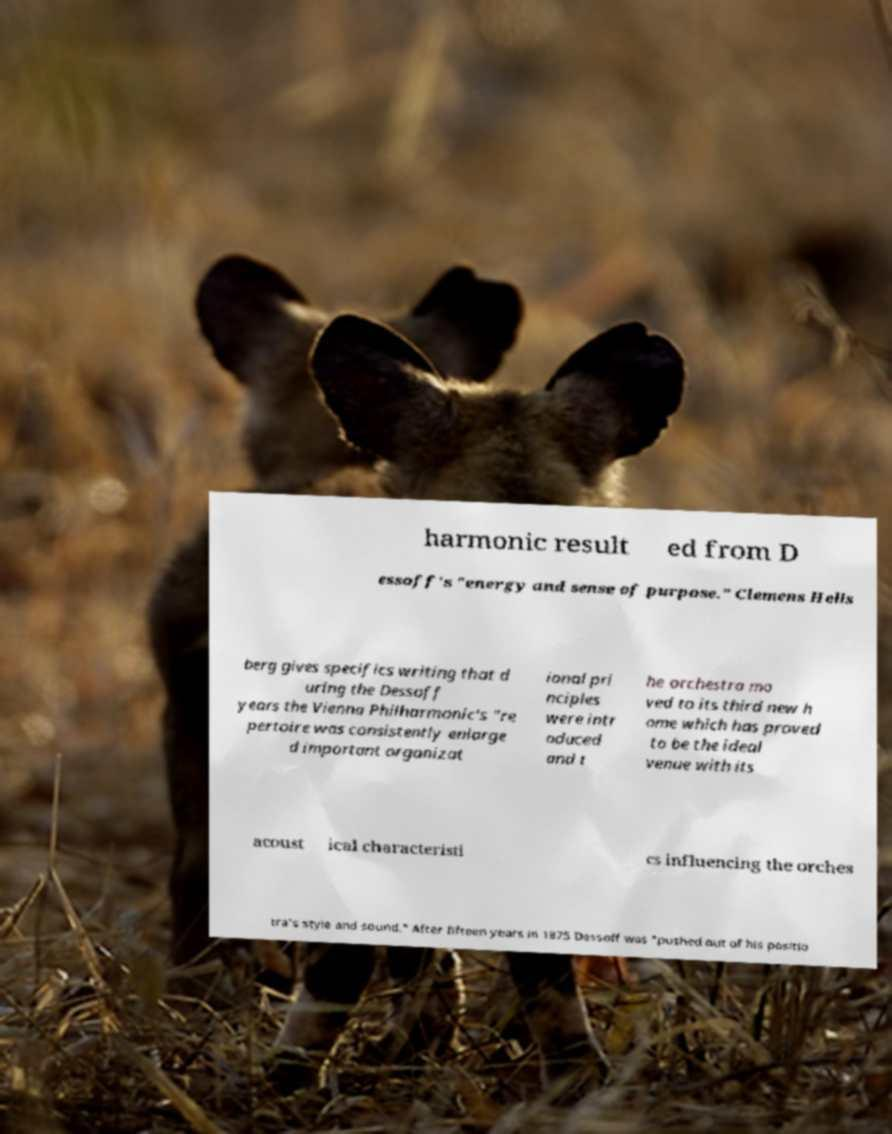Please identify and transcribe the text found in this image. harmonic result ed from D essoff's "energy and sense of purpose." Clemens Hells berg gives specifics writing that d uring the Dessoff years the Vienna Philharmonic's "re pertoire was consistently enlarge d important organizat ional pri nciples were intr oduced and t he orchestra mo ved to its third new h ome which has proved to be the ideal venue with its acoust ical characteristi cs influencing the orches tra's style and sound." After fifteen years in 1875 Dessoff was "pushed out of his positio 